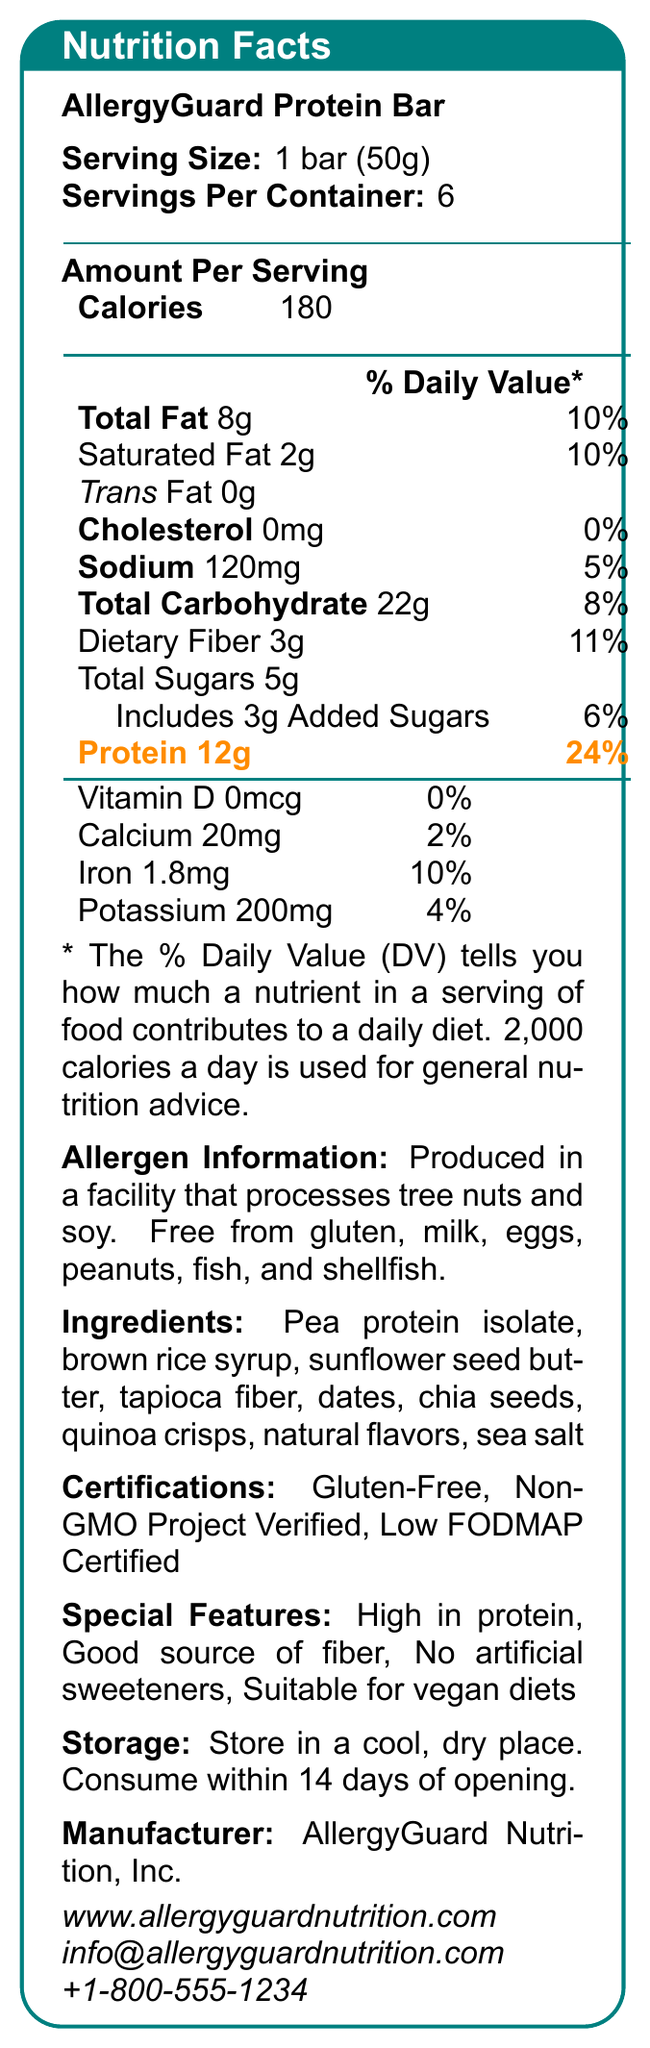what is the serving size for the AllergyGuard Protein Bar? The serving size is clearly listed at the top of the nutritional facts as "Serving Size: 1 bar (50g)".
Answer: 1 bar (50g) how many servings are in each container? The number of servings per container is indicated as "Servings Per Container: 6".
Answer: 6 what is the protein content per serving? The document highlights the protein content in orange as "Protein 12g".
Answer: 12g how much calcium is in one serving? The calcium amount is provided as "Calcium 20mg".
Answer: 20mg does the product contain any gluten? The allergen information states that the product is "Free from gluten".
Answer: No what percentage of the daily value of protein does one serving provide? The protein daily value is indicated as "24%", highlighted in orange.
Answer: 24% which certifications does the AllergyGuard Protein Bar hold? The certifications are listed under the "Certifications" section.
Answer: Gluten-Free, Non-GMO Project Verified, Low FODMAP Certified how much total fat is in one serving? A. 10g B. 8g C. 12g D. 5g The total fat amount is given as "Total Fat 8g".
Answer: B what is the dietary fiber content per serving? A. 4g B. 5g C. 2g D. 3g The dietary fiber per serving is listed as "Dietary Fiber 3g".
Answer: D is this product suitable for vegan diets? Under "Special Features", it is stated that the product is suitable for vegan diets.
Answer: Yes does this product contain any added sugars? The document indicates "Includes 3g Added Sugars".
Answer: Yes describe the main idea of the document. The document's main idea centers around providing detailed nutritional data and other relevant information about the AllergyGuard Protein Bar, emphasizing its suitability for individuals with allergies and dietary restrictions.
Answer: The document provides nutritional information for the AllergyGuard Protein Bar, highlighting its gluten-free, high-protein, and low-allergen features. It includes serving size, nutrient contents, allergen information, ingredients, certifications, special features, storage instructions, and manufacturer details. how much Vitamin D does one serving contain? The amount of Vitamin D is listed as "Vitamin D 0mcg".
Answer: 0mcg does the product include milk and egg allergens? The allergen information section confirms that the product is "Free from milk, eggs".
Answer: No how many calories are there per serving? The number of calories per serving is stated as "Calories 180".
Answer: 180 what are some of the ingredients used in the AllergyGuard Protein Bar? The ingredients are listed in the "Ingredients" section.
Answer: Pea protein isolate, brown rice syrup, sunflower seed butter, tapioca fiber, dates, chia seeds, quinoa crisps, natural flavors, sea salt which company manufactures the AllergyGuard Protein Bar? The document states "Manufacturer: AllergyGuard Nutrition, Inc.".
Answer: AllergyGuard Nutrition, Inc. can this document tell me the exact facility where the product is made? The document does not provide specific details about the facility, only that it processes tree nuts and soy.
Answer: Not enough information what is the sodium content per serving? A. 100mg B. 130mg C. 90mg D. 120mg The sodium content is listed as "Sodium 120mg".
Answer: D does one serving of this bar provide any cholesterol? The document indicates "Cholesterol 0mg".
Answer: No what contact information is available for the manufacturer? The contact information is provided at the bottom of the document.
Answer: www.allergyguardnutrition.com, info@allergyguardnutrition.com, +1-800-555-1234 